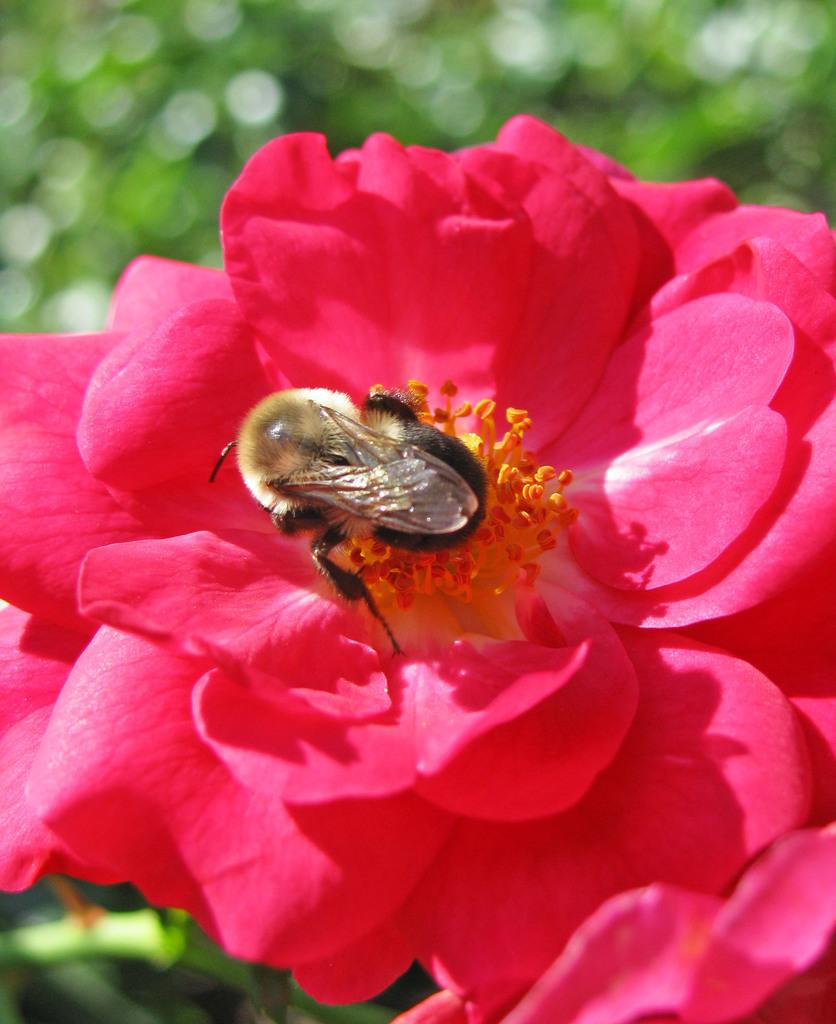What is on the flower in the image? There is a bee on a flower in the image. What can be seen in the background of the image? There are trees in the background of the image. How loud is the cough in the image? There is no cough present in the image. 